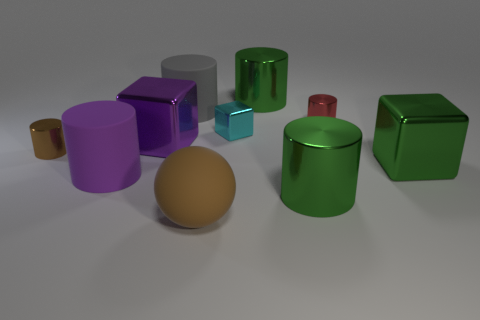If these objects were part of a toy set, which ages would it be suitable for? Assuming these objects are part of a toy set, they would likely be suitable for children aged three and above due to the absence of small parts that pose a choking hazard and the presence of simple geometric shapes that could aid cognitive development. 